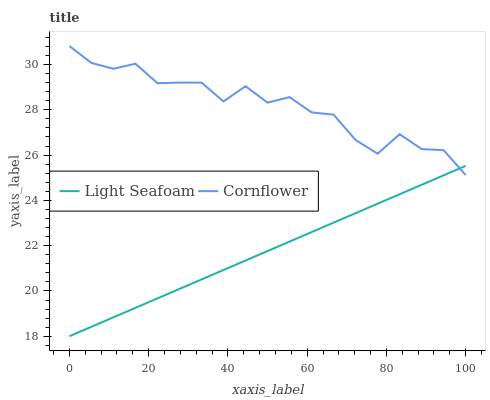Does Light Seafoam have the minimum area under the curve?
Answer yes or no. Yes. Does Cornflower have the maximum area under the curve?
Answer yes or no. Yes. Does Light Seafoam have the maximum area under the curve?
Answer yes or no. No. Is Light Seafoam the smoothest?
Answer yes or no. Yes. Is Cornflower the roughest?
Answer yes or no. Yes. Is Light Seafoam the roughest?
Answer yes or no. No. Does Light Seafoam have the lowest value?
Answer yes or no. Yes. Does Cornflower have the highest value?
Answer yes or no. Yes. Does Light Seafoam have the highest value?
Answer yes or no. No. Does Light Seafoam intersect Cornflower?
Answer yes or no. Yes. Is Light Seafoam less than Cornflower?
Answer yes or no. No. Is Light Seafoam greater than Cornflower?
Answer yes or no. No. 